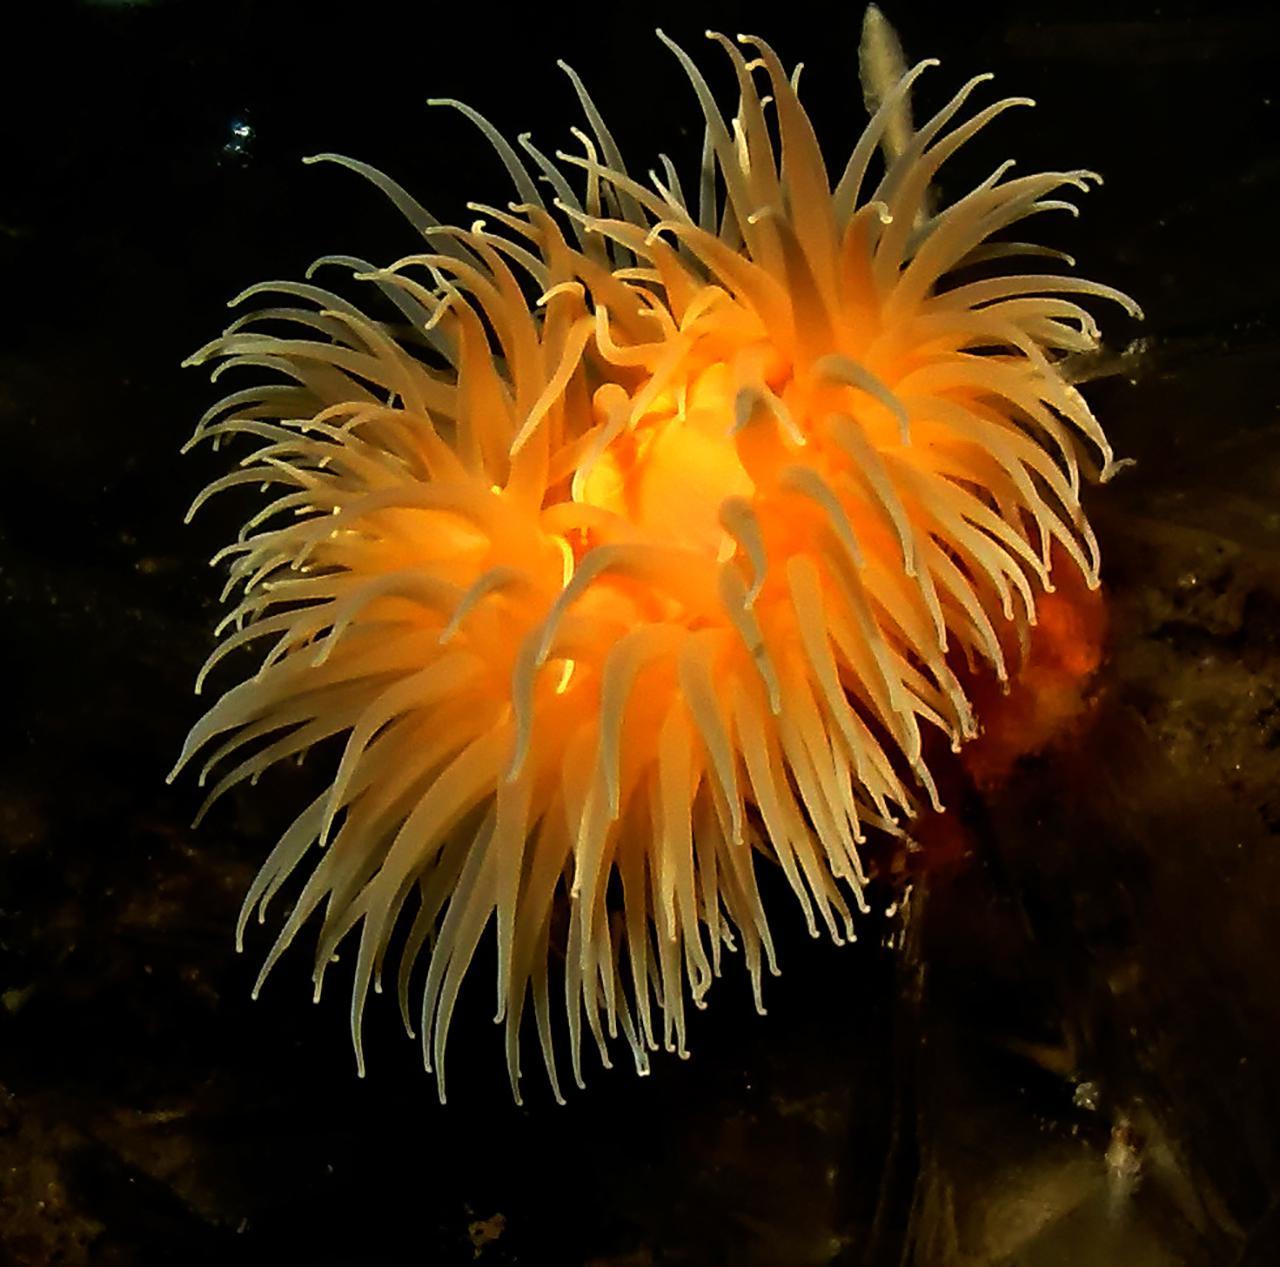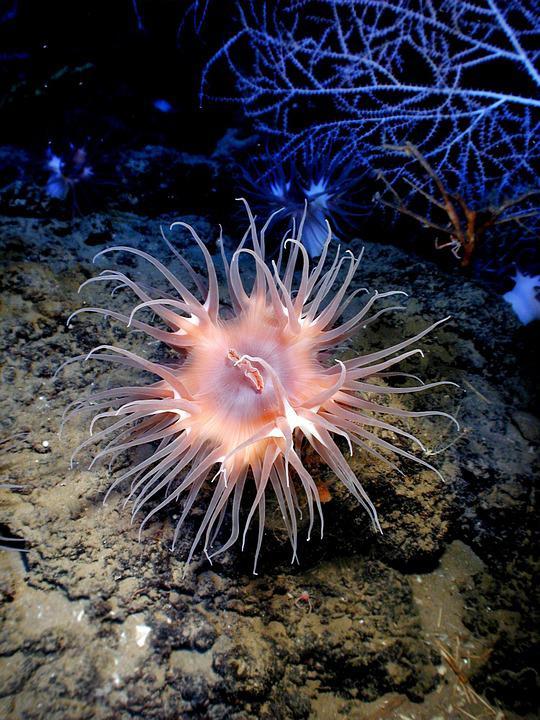The first image is the image on the left, the second image is the image on the right. Analyze the images presented: Is the assertion "One sea anemone has a visible mouth." valid? Answer yes or no. Yes. 